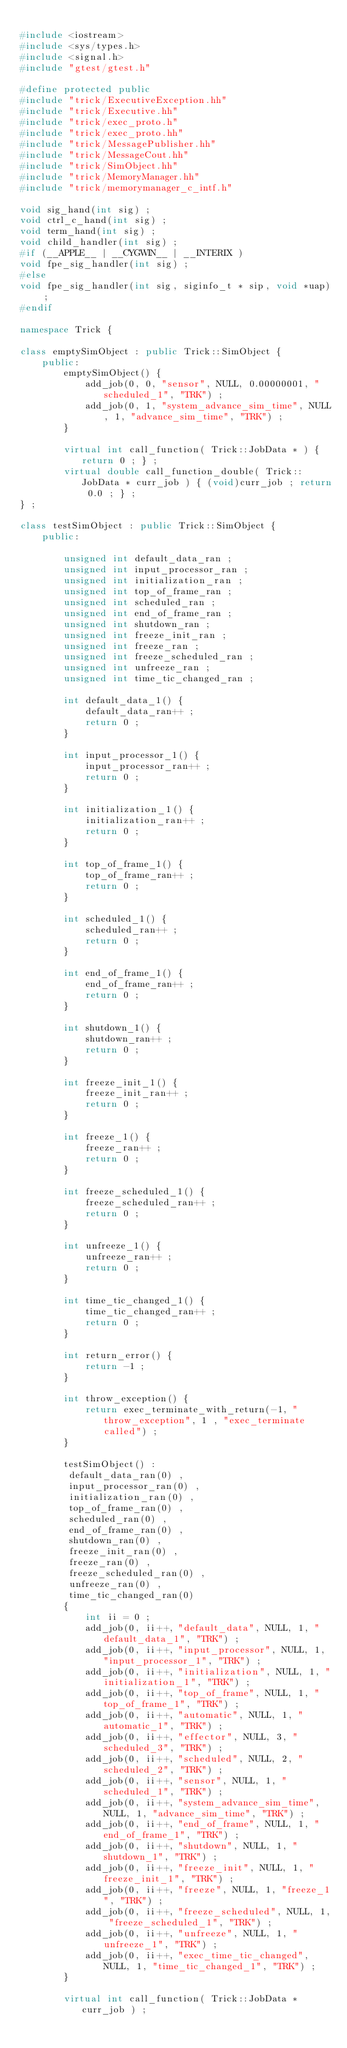Convert code to text. <code><loc_0><loc_0><loc_500><loc_500><_C++_>
#include <iostream>
#include <sys/types.h>
#include <signal.h>
#include "gtest/gtest.h"

#define protected public
#include "trick/ExecutiveException.hh"
#include "trick/Executive.hh"
#include "trick/exec_proto.h"
#include "trick/exec_proto.hh"
#include "trick/MessagePublisher.hh"
#include "trick/MessageCout.hh"
#include "trick/SimObject.hh"
#include "trick/MemoryManager.hh"
#include "trick/memorymanager_c_intf.h"

void sig_hand(int sig) ;
void ctrl_c_hand(int sig) ;
void term_hand(int sig) ;
void child_handler(int sig) ;
#if (__APPLE__ | __CYGWIN__ | __INTERIX )
void fpe_sig_handler(int sig) ;
#else
void fpe_sig_handler(int sig, siginfo_t * sip, void *uap) ;
#endif

namespace Trick {

class emptySimObject : public Trick::SimObject {
    public:
        emptySimObject() {
            add_job(0, 0, "sensor", NULL, 0.00000001, "scheduled_1", "TRK") ;
            add_job(0, 1, "system_advance_sim_time", NULL, 1, "advance_sim_time", "TRK") ;
        }

        virtual int call_function( Trick::JobData * ) { return 0 ; } ;
        virtual double call_function_double( Trick::JobData * curr_job ) { (void)curr_job ; return 0.0 ; } ;
} ;

class testSimObject : public Trick::SimObject {
    public:

        unsigned int default_data_ran ;
        unsigned int input_processor_ran ;
        unsigned int initialization_ran ;
        unsigned int top_of_frame_ran ;
        unsigned int scheduled_ran ;
        unsigned int end_of_frame_ran ;
        unsigned int shutdown_ran ;
        unsigned int freeze_init_ran ;
        unsigned int freeze_ran ;
        unsigned int freeze_scheduled_ran ;
        unsigned int unfreeze_ran ;
        unsigned int time_tic_changed_ran ;

        int default_data_1() {
            default_data_ran++ ;
            return 0 ;
        }

        int input_processor_1() {
            input_processor_ran++ ;
            return 0 ;
        }

        int initialization_1() {
            initialization_ran++ ;
            return 0 ;
        }

        int top_of_frame_1() {
            top_of_frame_ran++ ;
            return 0 ;
        }

        int scheduled_1() {
            scheduled_ran++ ;
            return 0 ;
        }

        int end_of_frame_1() {
            end_of_frame_ran++ ;
            return 0 ;
        }

        int shutdown_1() {
            shutdown_ran++ ;
            return 0 ;
        }

        int freeze_init_1() {
            freeze_init_ran++ ;
            return 0 ;
        }

        int freeze_1() {
            freeze_ran++ ;
            return 0 ;
        }

        int freeze_scheduled_1() {
            freeze_scheduled_ran++ ;
            return 0 ;
        }

        int unfreeze_1() {
            unfreeze_ran++ ;
            return 0 ;
        }

        int time_tic_changed_1() {
            time_tic_changed_ran++ ;
            return 0 ;
        }

        int return_error() {
            return -1 ;
        }

        int throw_exception() {
            return exec_terminate_with_return(-1, "throw_exception", 1 , "exec_terminate called") ;
        }

        testSimObject() :
         default_data_ran(0) ,
         input_processor_ran(0) ,
         initialization_ran(0) ,
         top_of_frame_ran(0) ,
         scheduled_ran(0) ,
         end_of_frame_ran(0) ,
         shutdown_ran(0) ,
         freeze_init_ran(0) ,
         freeze_ran(0) ,
         freeze_scheduled_ran(0) ,
         unfreeze_ran(0) ,
         time_tic_changed_ran(0)
        {
            int ii = 0 ;
            add_job(0, ii++, "default_data", NULL, 1, "default_data_1", "TRK") ;
            add_job(0, ii++, "input_processor", NULL, 1, "input_processor_1", "TRK") ;
            add_job(0, ii++, "initialization", NULL, 1, "initialization_1", "TRK") ;
            add_job(0, ii++, "top_of_frame", NULL, 1, "top_of_frame_1", "TRK") ;
            add_job(0, ii++, "automatic", NULL, 1, "automatic_1", "TRK") ;
            add_job(0, ii++, "effector", NULL, 3, "scheduled_3", "TRK") ;
            add_job(0, ii++, "scheduled", NULL, 2, "scheduled_2", "TRK") ;
            add_job(0, ii++, "sensor", NULL, 1, "scheduled_1", "TRK") ;
            add_job(0, ii++, "system_advance_sim_time", NULL, 1, "advance_sim_time", "TRK") ;
            add_job(0, ii++, "end_of_frame", NULL, 1, "end_of_frame_1", "TRK") ;
            add_job(0, ii++, "shutdown", NULL, 1, "shutdown_1", "TRK") ;
            add_job(0, ii++, "freeze_init", NULL, 1, "freeze_init_1", "TRK") ;
            add_job(0, ii++, "freeze", NULL, 1, "freeze_1", "TRK") ;
            add_job(0, ii++, "freeze_scheduled", NULL, 1, "freeze_scheduled_1", "TRK") ;
            add_job(0, ii++, "unfreeze", NULL, 1, "unfreeze_1", "TRK") ;
            add_job(0, ii++, "exec_time_tic_changed", NULL, 1, "time_tic_changed_1", "TRK") ;
        }

        virtual int call_function( Trick::JobData * curr_job ) ;</code> 